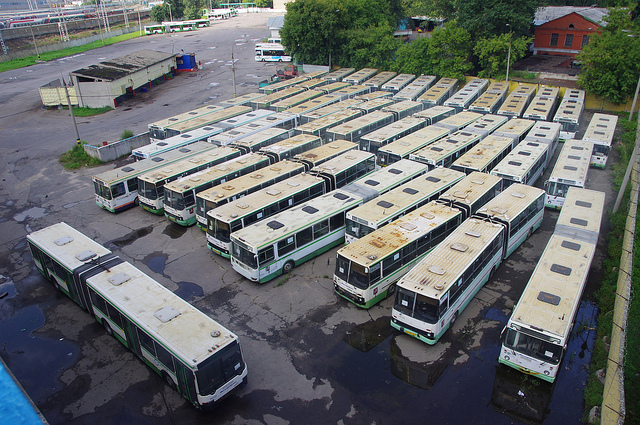<image>How many lanes are in the larger pool? I am not sure how many lanes are in the larger pool. It could be 1, 12, 20, 13, or 3. However, it seems there is no pool. How many lanes are in the larger pool? I don't know how many lanes are in the larger pool. 